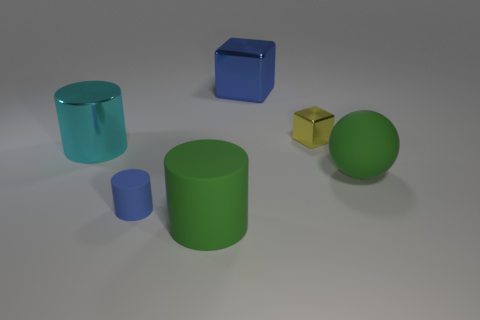Add 3 cyan shiny cylinders. How many objects exist? 9 Subtract all balls. How many objects are left? 5 Add 6 big rubber spheres. How many big rubber spheres are left? 7 Add 6 green rubber balls. How many green rubber balls exist? 7 Subtract 0 cyan spheres. How many objects are left? 6 Subtract all tiny brown rubber spheres. Subtract all blue matte cylinders. How many objects are left? 5 